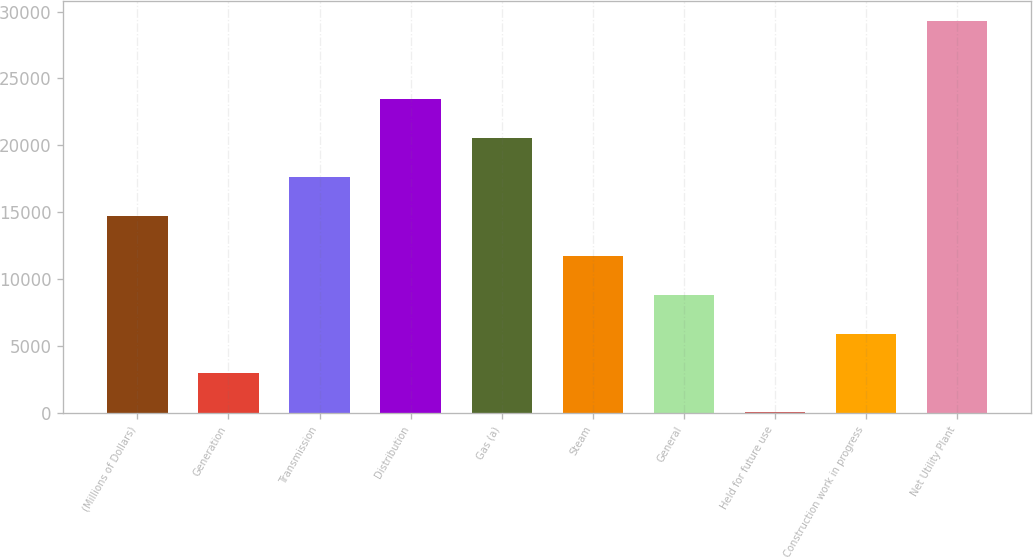Convert chart. <chart><loc_0><loc_0><loc_500><loc_500><bar_chart><fcel>(Millions of Dollars)<fcel>Generation<fcel>Transmission<fcel>Distribution<fcel>Gas (a)<fcel>Steam<fcel>General<fcel>Held for future use<fcel>Construction work in progress<fcel>Net Utility Plant<nl><fcel>14687.5<fcel>2989.5<fcel>17612<fcel>23461<fcel>20536.5<fcel>11763<fcel>8838.5<fcel>65<fcel>5914<fcel>29310<nl></chart> 